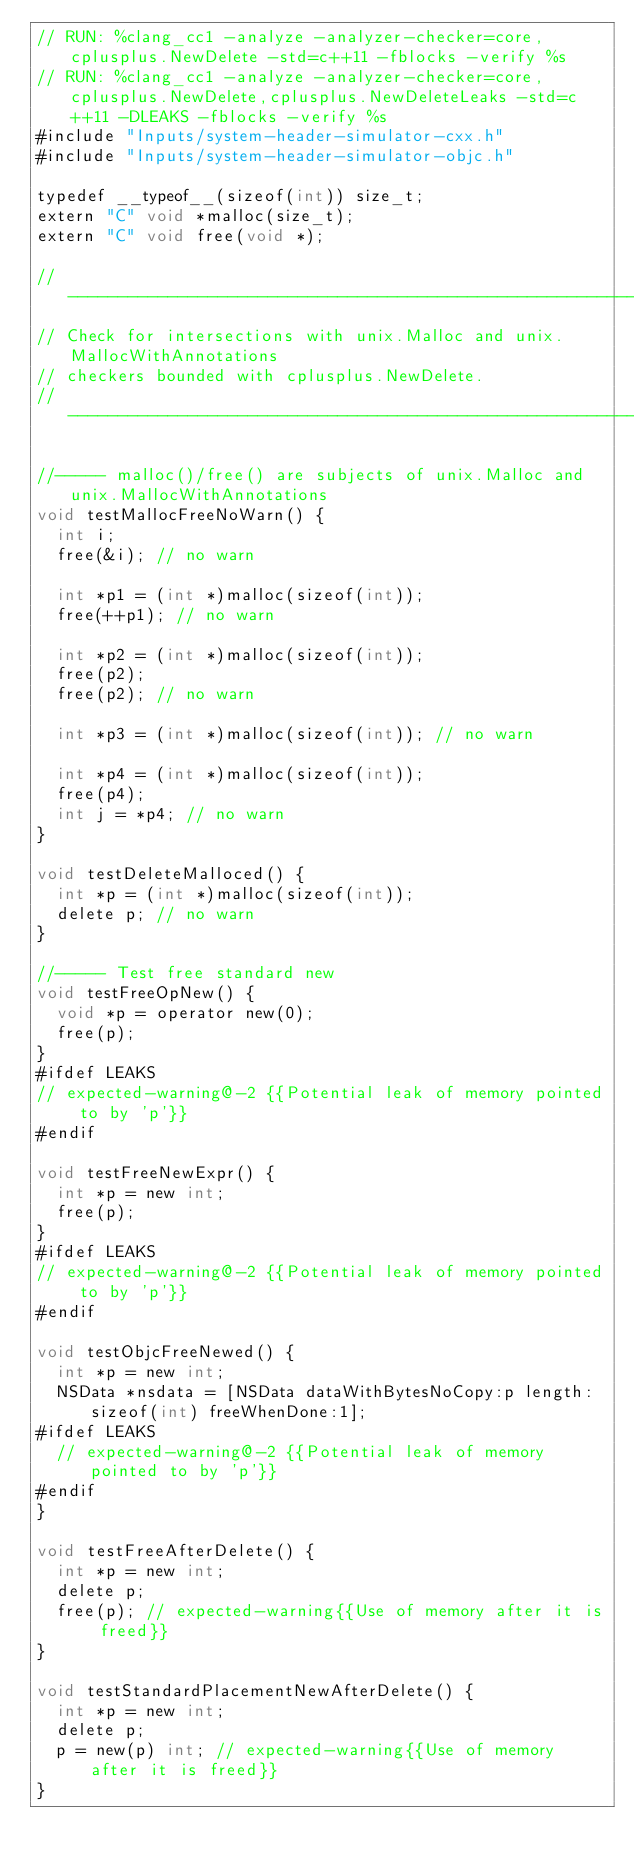Convert code to text. <code><loc_0><loc_0><loc_500><loc_500><_ObjectiveC_>// RUN: %clang_cc1 -analyze -analyzer-checker=core,cplusplus.NewDelete -std=c++11 -fblocks -verify %s
// RUN: %clang_cc1 -analyze -analyzer-checker=core,cplusplus.NewDelete,cplusplus.NewDeleteLeaks -std=c++11 -DLEAKS -fblocks -verify %s
#include "Inputs/system-header-simulator-cxx.h"
#include "Inputs/system-header-simulator-objc.h"

typedef __typeof__(sizeof(int)) size_t;
extern "C" void *malloc(size_t);
extern "C" void free(void *);

//----------------------------------------------------------------------------
// Check for intersections with unix.Malloc and unix.MallocWithAnnotations 
// checkers bounded with cplusplus.NewDelete.
//----------------------------------------------------------------------------

//----- malloc()/free() are subjects of unix.Malloc and unix.MallocWithAnnotations
void testMallocFreeNoWarn() {
  int i;
  free(&i); // no warn

  int *p1 = (int *)malloc(sizeof(int));
  free(++p1); // no warn

  int *p2 = (int *)malloc(sizeof(int));
  free(p2);
  free(p2); // no warn

  int *p3 = (int *)malloc(sizeof(int)); // no warn

  int *p4 = (int *)malloc(sizeof(int));
  free(p4);
  int j = *p4; // no warn
}

void testDeleteMalloced() {
  int *p = (int *)malloc(sizeof(int));
  delete p; // no warn
} 

//----- Test free standard new
void testFreeOpNew() {
  void *p = operator new(0);
  free(p);
}
#ifdef LEAKS
// expected-warning@-2 {{Potential leak of memory pointed to by 'p'}}
#endif

void testFreeNewExpr() {
  int *p = new int;
  free(p);
}
#ifdef LEAKS
// expected-warning@-2 {{Potential leak of memory pointed to by 'p'}}
#endif

void testObjcFreeNewed() {
  int *p = new int;
  NSData *nsdata = [NSData dataWithBytesNoCopy:p length:sizeof(int) freeWhenDone:1];
#ifdef LEAKS
  // expected-warning@-2 {{Potential leak of memory pointed to by 'p'}}
#endif
}

void testFreeAfterDelete() {
  int *p = new int;  
  delete p;
  free(p); // expected-warning{{Use of memory after it is freed}}
}

void testStandardPlacementNewAfterDelete() {
  int *p = new int;  
  delete p;
  p = new(p) int; // expected-warning{{Use of memory after it is freed}}
}
</code> 